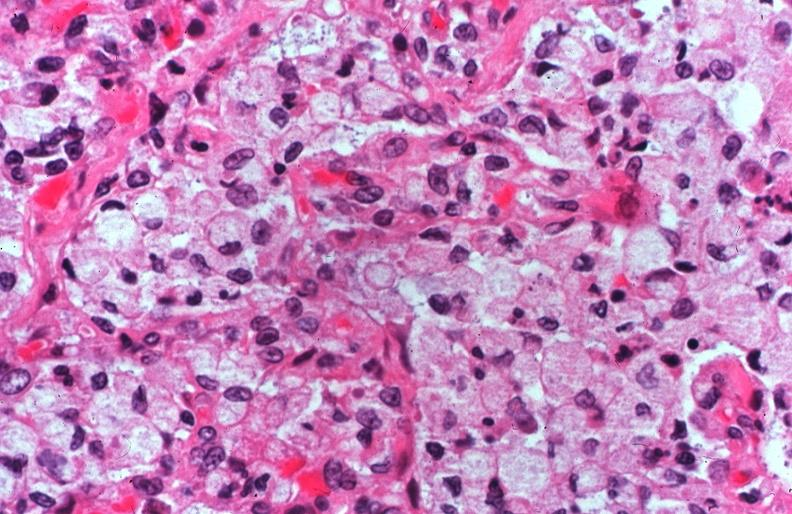s 70yof present?
Answer the question using a single word or phrase. No 